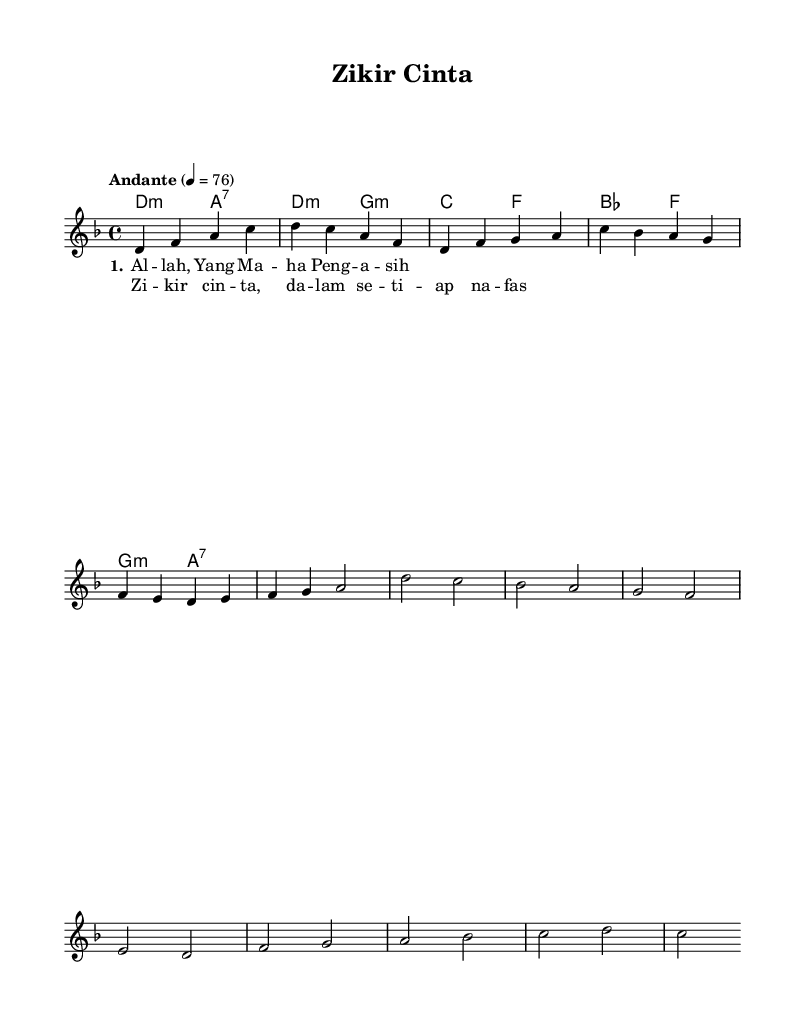What is the key signature of this music? The key signature is D minor, which contains one flat (B♭) and is indicated at the beginning of the music.
Answer: D minor What is the time signature of this piece? The time signature is 4/4, which indicates there are four beats in each measure and the quarter note gets one beat.
Answer: 4/4 What is the tempo marking given for this composition? The tempo marking is "Andante," which generally suggests a moderately slow tempo, typically ranging around 76 beats per minute.
Answer: Andante How many measures are in the chorus? The chorus consists of 4 measures based on the grouping of the notes and rests represented in the sheet music.
Answer: 4 What is the first word of the verse lyrics? The first word of the verse lyrics is "Al," as seen in the lyric section underneath the melody.
Answer: Al What chords are used in the chorus? The chords used in the chorus are B♭, F, G minor, and A7, as indicated in the chord section corresponding to the measures of the chorus.
Answer: B♭, F, G minor, A7 What is the last note of the melody? The last note of the melody is C, as shown in the final measure of the melody line in the score.
Answer: C 